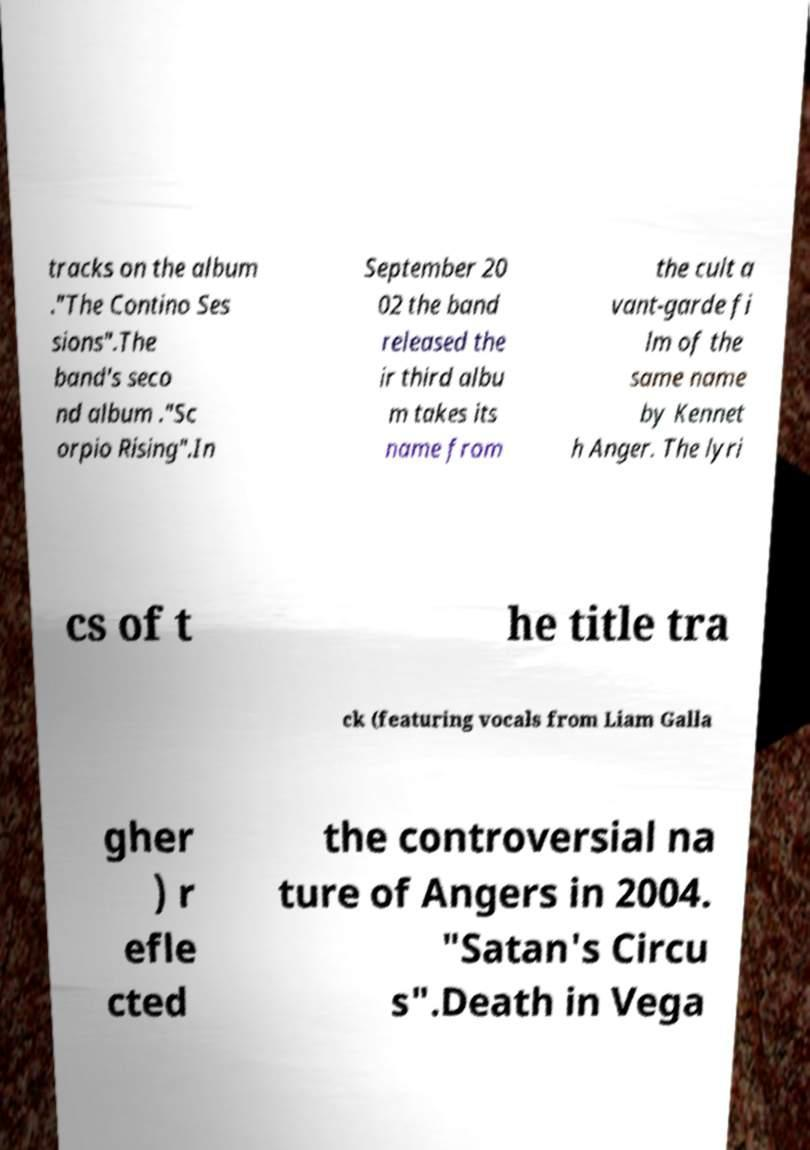Please read and relay the text visible in this image. What does it say? tracks on the album ."The Contino Ses sions".The band's seco nd album ."Sc orpio Rising".In September 20 02 the band released the ir third albu m takes its name from the cult a vant-garde fi lm of the same name by Kennet h Anger. The lyri cs of t he title tra ck (featuring vocals from Liam Galla gher ) r efle cted the controversial na ture of Angers in 2004. "Satan's Circu s".Death in Vega 